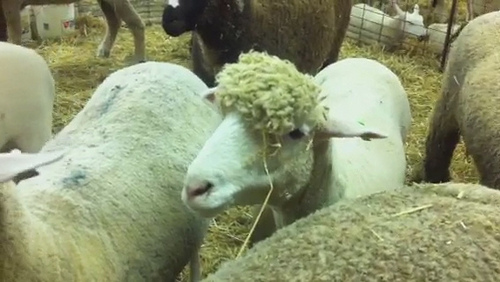If there were a festival for sheep in this pen, what activities would you imagine there being? At a sheep festival, activities would include a 'Best Wool' contest, a hay-eating competition, and a race to see which sheep can navigate around the pen the fastest. There would be a musical performance featuring the gentle bleats of the sheep harmonizing with a farm concert. A storytelling corner where lambs gather to hear tales from the oldest sheep would be popular. Additionally, there would be a parade showcasing beautifully adorned sheep wearing flower garlands. 